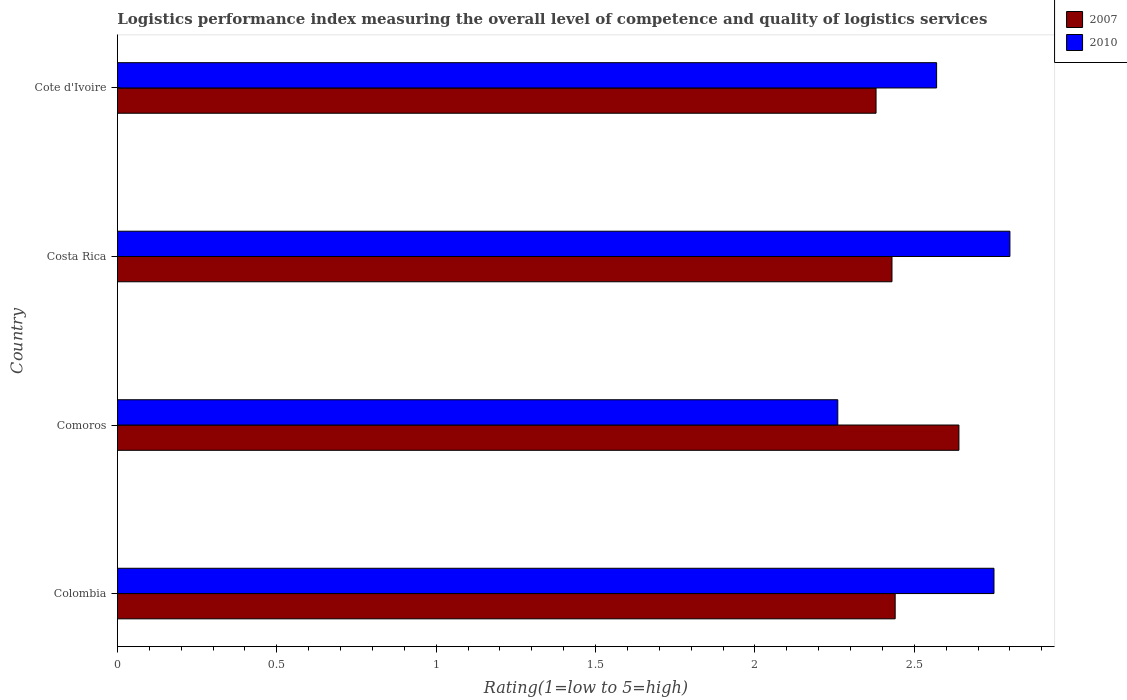Are the number of bars per tick equal to the number of legend labels?
Ensure brevity in your answer.  Yes. Are the number of bars on each tick of the Y-axis equal?
Provide a short and direct response. Yes. How many bars are there on the 3rd tick from the top?
Your answer should be compact. 2. What is the label of the 1st group of bars from the top?
Offer a very short reply. Cote d'Ivoire. In how many cases, is the number of bars for a given country not equal to the number of legend labels?
Provide a succinct answer. 0. What is the Logistic performance index in 2010 in Comoros?
Ensure brevity in your answer.  2.26. Across all countries, what is the maximum Logistic performance index in 2007?
Keep it short and to the point. 2.64. Across all countries, what is the minimum Logistic performance index in 2007?
Your answer should be compact. 2.38. In which country was the Logistic performance index in 2007 maximum?
Give a very brief answer. Comoros. In which country was the Logistic performance index in 2007 minimum?
Your answer should be compact. Cote d'Ivoire. What is the total Logistic performance index in 2010 in the graph?
Offer a very short reply. 10.38. What is the difference between the Logistic performance index in 2007 in Comoros and that in Cote d'Ivoire?
Keep it short and to the point. 0.26. What is the difference between the Logistic performance index in 2010 in Costa Rica and the Logistic performance index in 2007 in Cote d'Ivoire?
Your answer should be very brief. 0.42. What is the average Logistic performance index in 2010 per country?
Your response must be concise. 2.59. What is the difference between the Logistic performance index in 2010 and Logistic performance index in 2007 in Cote d'Ivoire?
Ensure brevity in your answer.  0.19. In how many countries, is the Logistic performance index in 2010 greater than 1.9 ?
Offer a very short reply. 4. What is the ratio of the Logistic performance index in 2010 in Costa Rica to that in Cote d'Ivoire?
Ensure brevity in your answer.  1.09. Is the difference between the Logistic performance index in 2010 in Comoros and Cote d'Ivoire greater than the difference between the Logistic performance index in 2007 in Comoros and Cote d'Ivoire?
Your answer should be very brief. No. What is the difference between the highest and the second highest Logistic performance index in 2010?
Your response must be concise. 0.05. What is the difference between the highest and the lowest Logistic performance index in 2010?
Give a very brief answer. 0.54. In how many countries, is the Logistic performance index in 2010 greater than the average Logistic performance index in 2010 taken over all countries?
Make the answer very short. 2. How many countries are there in the graph?
Your answer should be compact. 4. Are the values on the major ticks of X-axis written in scientific E-notation?
Offer a very short reply. No. Does the graph contain any zero values?
Offer a terse response. No. Does the graph contain grids?
Ensure brevity in your answer.  No. What is the title of the graph?
Ensure brevity in your answer.  Logistics performance index measuring the overall level of competence and quality of logistics services. Does "1977" appear as one of the legend labels in the graph?
Your response must be concise. No. What is the label or title of the X-axis?
Offer a very short reply. Rating(1=low to 5=high). What is the Rating(1=low to 5=high) in 2007 in Colombia?
Offer a very short reply. 2.44. What is the Rating(1=low to 5=high) in 2010 in Colombia?
Make the answer very short. 2.75. What is the Rating(1=low to 5=high) in 2007 in Comoros?
Your response must be concise. 2.64. What is the Rating(1=low to 5=high) of 2010 in Comoros?
Keep it short and to the point. 2.26. What is the Rating(1=low to 5=high) of 2007 in Costa Rica?
Your answer should be compact. 2.43. What is the Rating(1=low to 5=high) of 2010 in Costa Rica?
Ensure brevity in your answer.  2.8. What is the Rating(1=low to 5=high) in 2007 in Cote d'Ivoire?
Make the answer very short. 2.38. What is the Rating(1=low to 5=high) in 2010 in Cote d'Ivoire?
Make the answer very short. 2.57. Across all countries, what is the maximum Rating(1=low to 5=high) in 2007?
Give a very brief answer. 2.64. Across all countries, what is the minimum Rating(1=low to 5=high) in 2007?
Make the answer very short. 2.38. Across all countries, what is the minimum Rating(1=low to 5=high) in 2010?
Keep it short and to the point. 2.26. What is the total Rating(1=low to 5=high) of 2007 in the graph?
Keep it short and to the point. 9.89. What is the total Rating(1=low to 5=high) of 2010 in the graph?
Ensure brevity in your answer.  10.38. What is the difference between the Rating(1=low to 5=high) in 2010 in Colombia and that in Comoros?
Your answer should be very brief. 0.49. What is the difference between the Rating(1=low to 5=high) in 2010 in Colombia and that in Costa Rica?
Make the answer very short. -0.05. What is the difference between the Rating(1=low to 5=high) of 2007 in Colombia and that in Cote d'Ivoire?
Your answer should be very brief. 0.06. What is the difference between the Rating(1=low to 5=high) in 2010 in Colombia and that in Cote d'Ivoire?
Your answer should be compact. 0.18. What is the difference between the Rating(1=low to 5=high) of 2007 in Comoros and that in Costa Rica?
Your response must be concise. 0.21. What is the difference between the Rating(1=low to 5=high) of 2010 in Comoros and that in Costa Rica?
Keep it short and to the point. -0.54. What is the difference between the Rating(1=low to 5=high) of 2007 in Comoros and that in Cote d'Ivoire?
Offer a terse response. 0.26. What is the difference between the Rating(1=low to 5=high) of 2010 in Comoros and that in Cote d'Ivoire?
Your answer should be compact. -0.31. What is the difference between the Rating(1=low to 5=high) in 2010 in Costa Rica and that in Cote d'Ivoire?
Offer a terse response. 0.23. What is the difference between the Rating(1=low to 5=high) in 2007 in Colombia and the Rating(1=low to 5=high) in 2010 in Comoros?
Give a very brief answer. 0.18. What is the difference between the Rating(1=low to 5=high) in 2007 in Colombia and the Rating(1=low to 5=high) in 2010 in Costa Rica?
Offer a terse response. -0.36. What is the difference between the Rating(1=low to 5=high) of 2007 in Colombia and the Rating(1=low to 5=high) of 2010 in Cote d'Ivoire?
Your response must be concise. -0.13. What is the difference between the Rating(1=low to 5=high) of 2007 in Comoros and the Rating(1=low to 5=high) of 2010 in Costa Rica?
Provide a succinct answer. -0.16. What is the difference between the Rating(1=low to 5=high) in 2007 in Comoros and the Rating(1=low to 5=high) in 2010 in Cote d'Ivoire?
Offer a terse response. 0.07. What is the difference between the Rating(1=low to 5=high) in 2007 in Costa Rica and the Rating(1=low to 5=high) in 2010 in Cote d'Ivoire?
Make the answer very short. -0.14. What is the average Rating(1=low to 5=high) in 2007 per country?
Your answer should be very brief. 2.47. What is the average Rating(1=low to 5=high) in 2010 per country?
Offer a very short reply. 2.6. What is the difference between the Rating(1=low to 5=high) of 2007 and Rating(1=low to 5=high) of 2010 in Colombia?
Provide a short and direct response. -0.31. What is the difference between the Rating(1=low to 5=high) of 2007 and Rating(1=low to 5=high) of 2010 in Comoros?
Make the answer very short. 0.38. What is the difference between the Rating(1=low to 5=high) in 2007 and Rating(1=low to 5=high) in 2010 in Costa Rica?
Offer a very short reply. -0.37. What is the difference between the Rating(1=low to 5=high) of 2007 and Rating(1=low to 5=high) of 2010 in Cote d'Ivoire?
Your response must be concise. -0.19. What is the ratio of the Rating(1=low to 5=high) in 2007 in Colombia to that in Comoros?
Provide a succinct answer. 0.92. What is the ratio of the Rating(1=low to 5=high) of 2010 in Colombia to that in Comoros?
Keep it short and to the point. 1.22. What is the ratio of the Rating(1=low to 5=high) in 2007 in Colombia to that in Costa Rica?
Offer a terse response. 1. What is the ratio of the Rating(1=low to 5=high) in 2010 in Colombia to that in Costa Rica?
Make the answer very short. 0.98. What is the ratio of the Rating(1=low to 5=high) in 2007 in Colombia to that in Cote d'Ivoire?
Ensure brevity in your answer.  1.03. What is the ratio of the Rating(1=low to 5=high) in 2010 in Colombia to that in Cote d'Ivoire?
Offer a terse response. 1.07. What is the ratio of the Rating(1=low to 5=high) of 2007 in Comoros to that in Costa Rica?
Your response must be concise. 1.09. What is the ratio of the Rating(1=low to 5=high) in 2010 in Comoros to that in Costa Rica?
Your answer should be very brief. 0.81. What is the ratio of the Rating(1=low to 5=high) in 2007 in Comoros to that in Cote d'Ivoire?
Provide a short and direct response. 1.11. What is the ratio of the Rating(1=low to 5=high) of 2010 in Comoros to that in Cote d'Ivoire?
Make the answer very short. 0.88. What is the ratio of the Rating(1=low to 5=high) of 2007 in Costa Rica to that in Cote d'Ivoire?
Offer a very short reply. 1.02. What is the ratio of the Rating(1=low to 5=high) of 2010 in Costa Rica to that in Cote d'Ivoire?
Keep it short and to the point. 1.09. What is the difference between the highest and the second highest Rating(1=low to 5=high) of 2010?
Offer a terse response. 0.05. What is the difference between the highest and the lowest Rating(1=low to 5=high) of 2007?
Your answer should be compact. 0.26. What is the difference between the highest and the lowest Rating(1=low to 5=high) in 2010?
Your answer should be very brief. 0.54. 